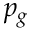Convert formula to latex. <formula><loc_0><loc_0><loc_500><loc_500>p _ { g }</formula> 